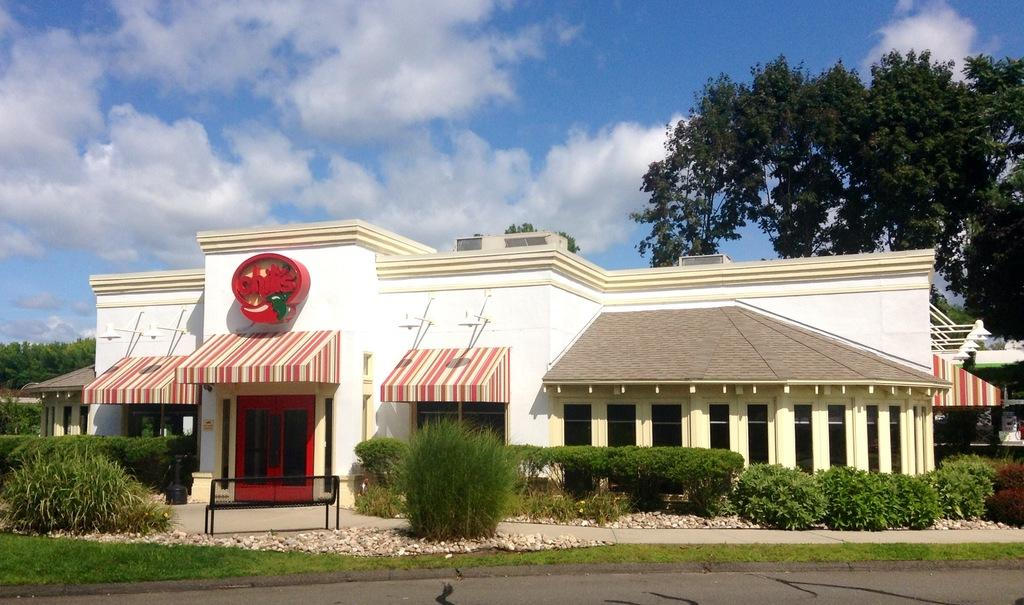<image>
Share a concise interpretation of the image provided. Chili's Restaurant surrounded by trees on a nice sunny day. 